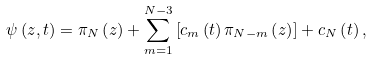Convert formula to latex. <formula><loc_0><loc_0><loc_500><loc_500>\psi \left ( z , t \right ) = \pi _ { N } \left ( z \right ) + \sum _ { m = 1 } ^ { N - 3 } \left [ c _ { m } \left ( t \right ) \pi _ { N - m } \left ( z \right ) \right ] + c _ { N } \left ( t \right ) ,</formula> 